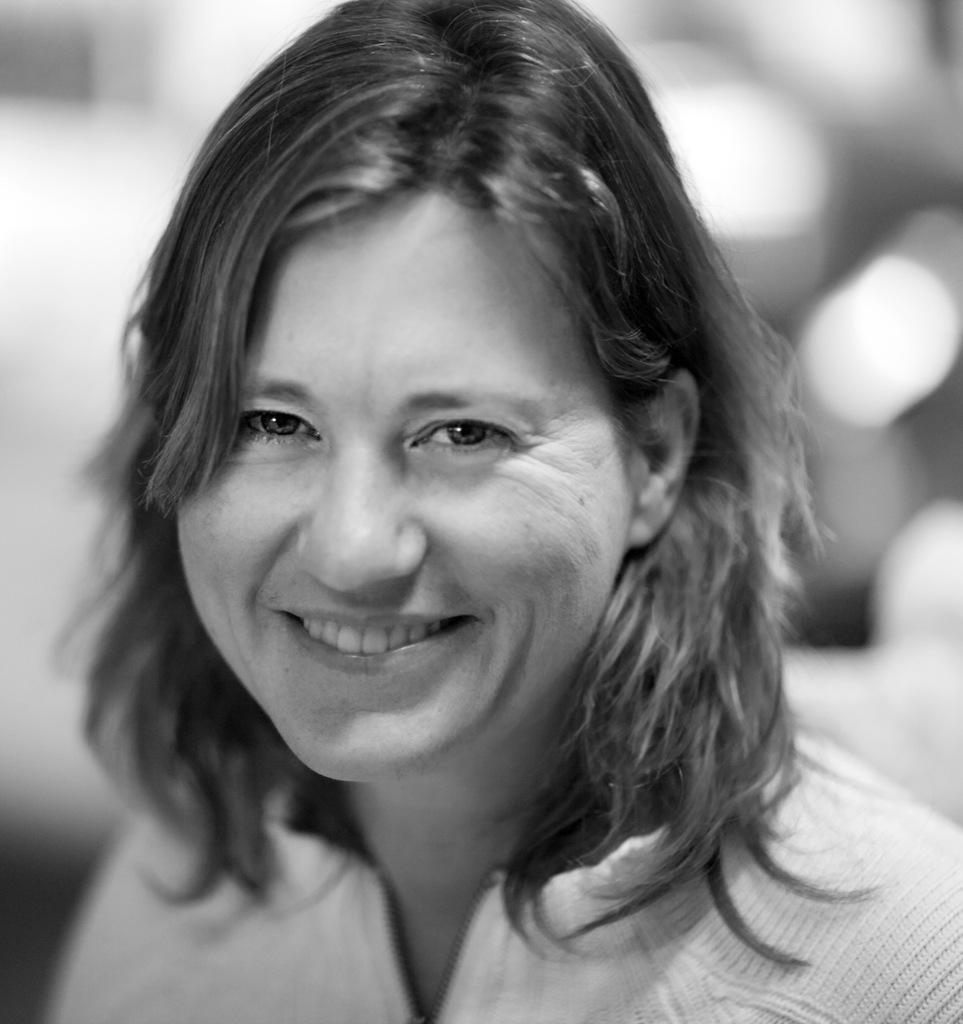Could you give a brief overview of what you see in this image? In this image truncated towards the bottom of the image, the background of the image is blurred. 